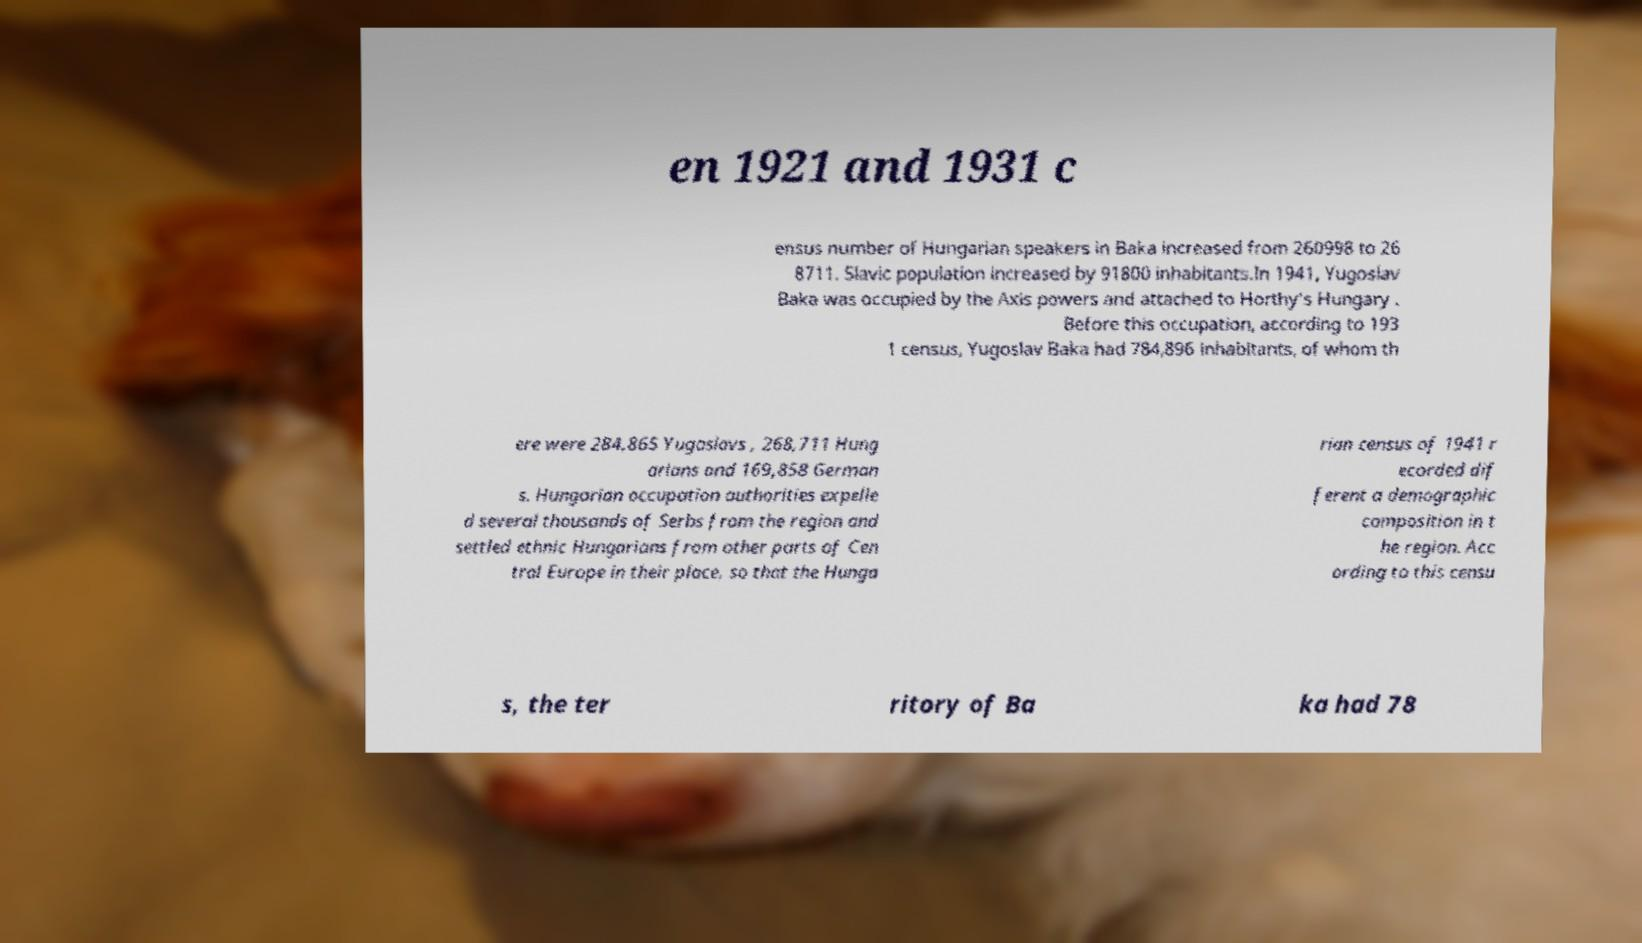Could you extract and type out the text from this image? en 1921 and 1931 c ensus number of Hungarian speakers in Baka increased from 260998 to 26 8711. Slavic population increased by 91800 inhabitants.In 1941, Yugoslav Baka was occupied by the Axis powers and attached to Horthy's Hungary . Before this occupation, according to 193 1 census, Yugoslav Baka had 784,896 inhabitants, of whom th ere were 284,865 Yugoslavs , 268,711 Hung arians and 169,858 German s. Hungarian occupation authorities expelle d several thousands of Serbs from the region and settled ethnic Hungarians from other parts of Cen tral Europe in their place, so that the Hunga rian census of 1941 r ecorded dif ferent a demographic composition in t he region. Acc ording to this censu s, the ter ritory of Ba ka had 78 